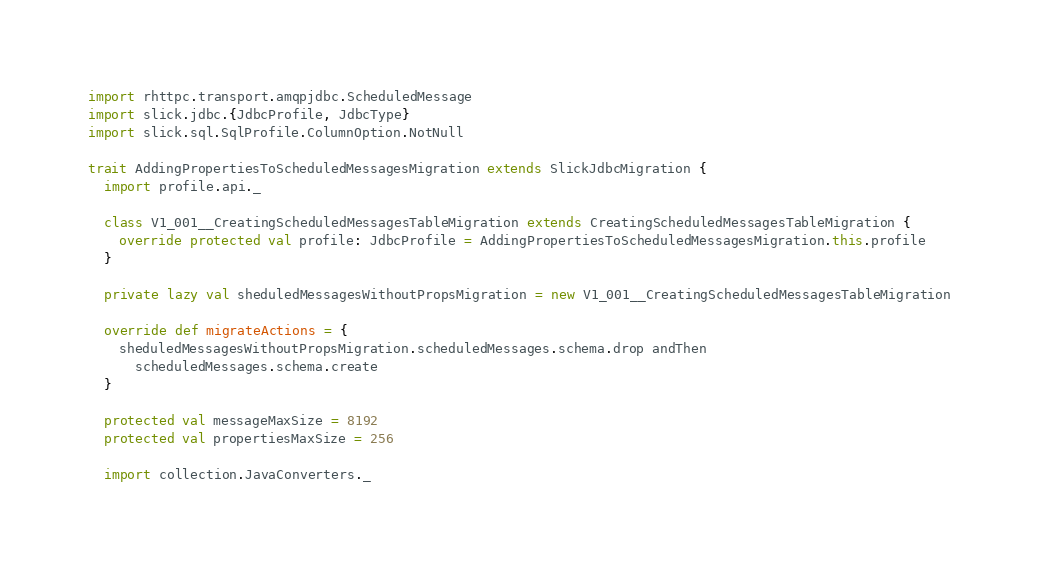<code> <loc_0><loc_0><loc_500><loc_500><_Scala_>import rhttpc.transport.amqpjdbc.ScheduledMessage
import slick.jdbc.{JdbcProfile, JdbcType}
import slick.sql.SqlProfile.ColumnOption.NotNull

trait AddingPropertiesToScheduledMessagesMigration extends SlickJdbcMigration {
  import profile.api._

  class V1_001__CreatingScheduledMessagesTableMigration extends CreatingScheduledMessagesTableMigration {
    override protected val profile: JdbcProfile = AddingPropertiesToScheduledMessagesMigration.this.profile
  }

  private lazy val sheduledMessagesWithoutPropsMigration = new V1_001__CreatingScheduledMessagesTableMigration

  override def migrateActions = {
    sheduledMessagesWithoutPropsMigration.scheduledMessages.schema.drop andThen
      scheduledMessages.schema.create
  }

  protected val messageMaxSize = 8192
  protected val propertiesMaxSize = 256

  import collection.JavaConverters._
</code> 